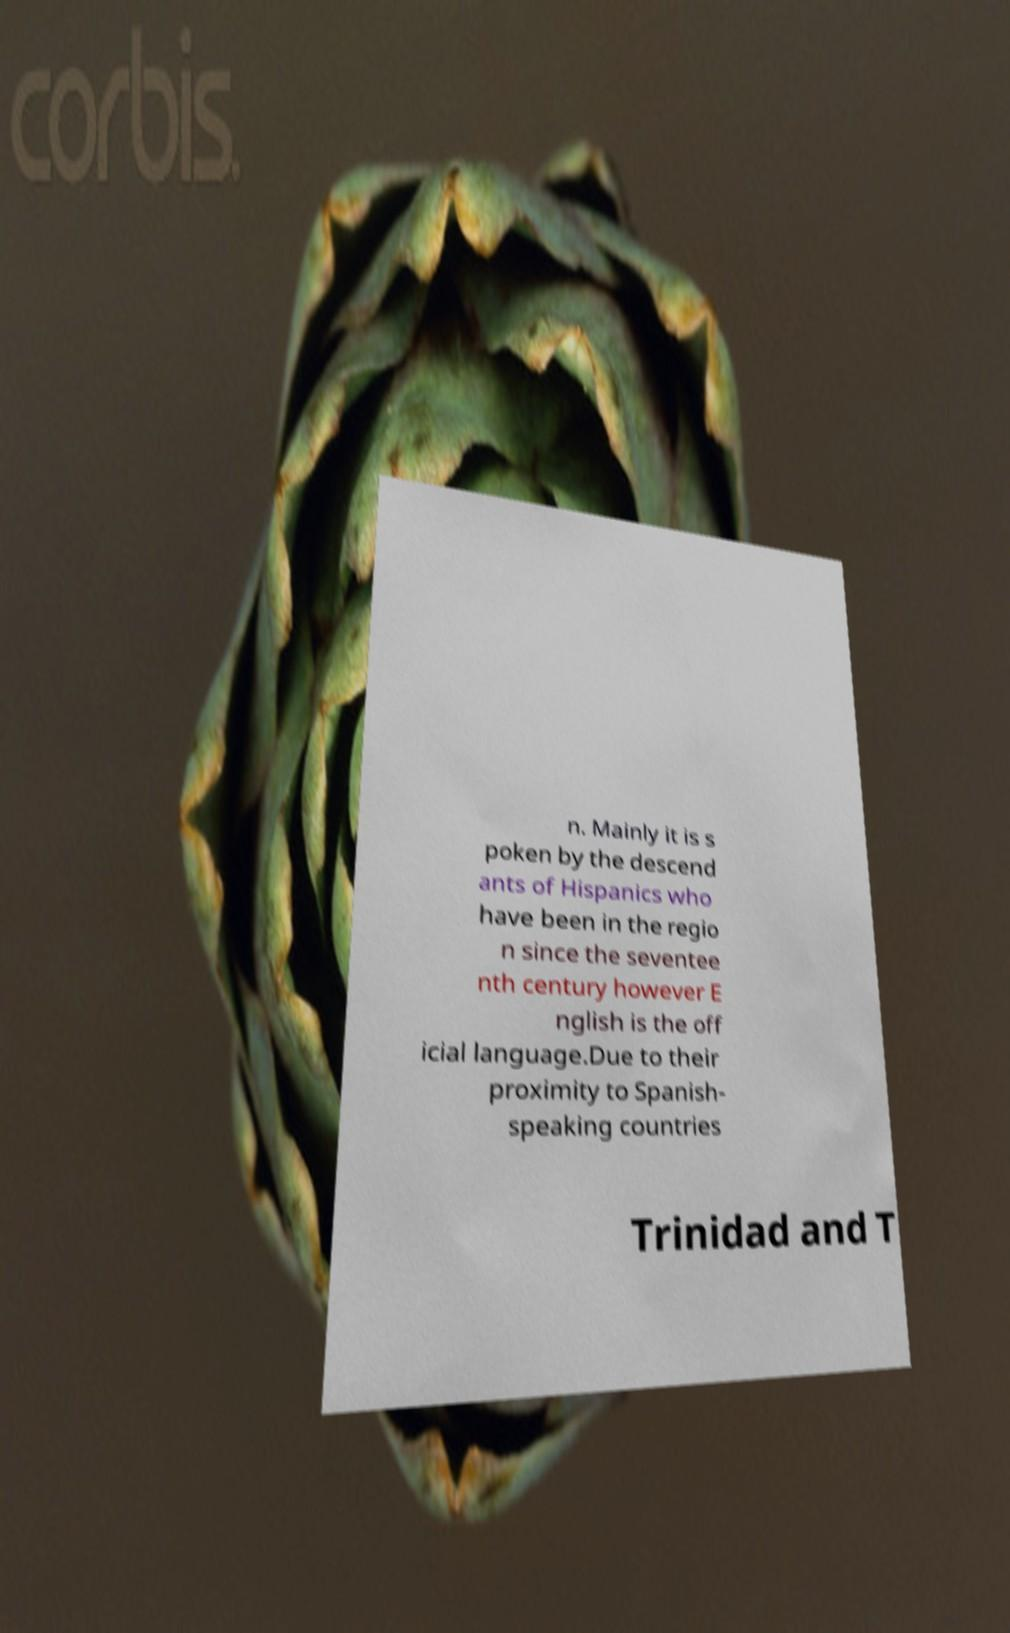There's text embedded in this image that I need extracted. Can you transcribe it verbatim? n. Mainly it is s poken by the descend ants of Hispanics who have been in the regio n since the seventee nth century however E nglish is the off icial language.Due to their proximity to Spanish- speaking countries Trinidad and T 